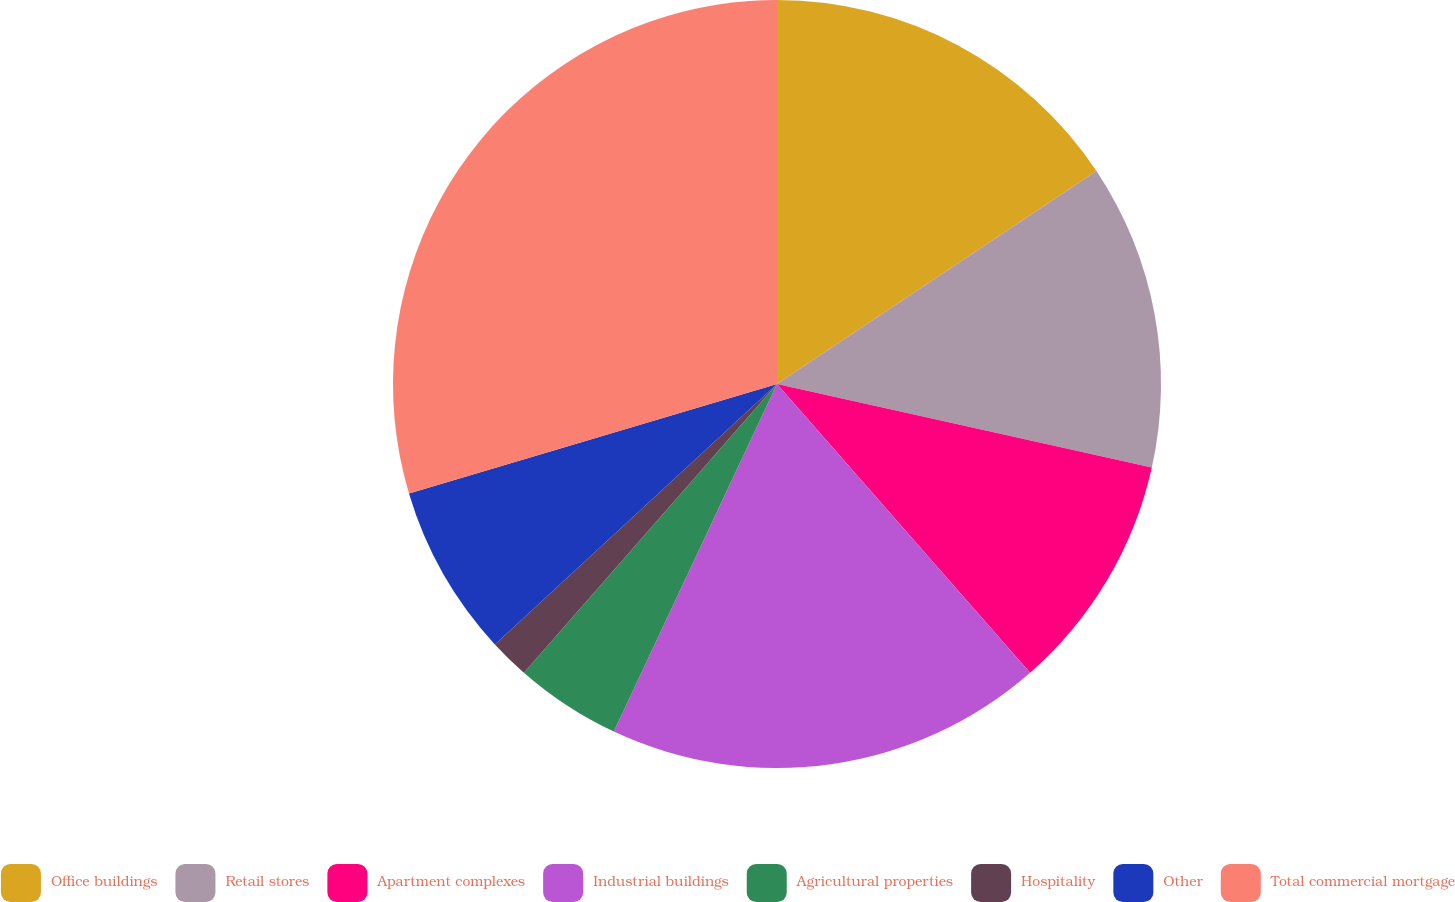Convert chart. <chart><loc_0><loc_0><loc_500><loc_500><pie_chart><fcel>Office buildings<fcel>Retail stores<fcel>Apartment complexes<fcel>Industrial buildings<fcel>Agricultural properties<fcel>Hospitality<fcel>Other<fcel>Total commercial mortgage<nl><fcel>15.64%<fcel>12.85%<fcel>10.06%<fcel>18.44%<fcel>4.47%<fcel>1.68%<fcel>7.26%<fcel>29.61%<nl></chart> 